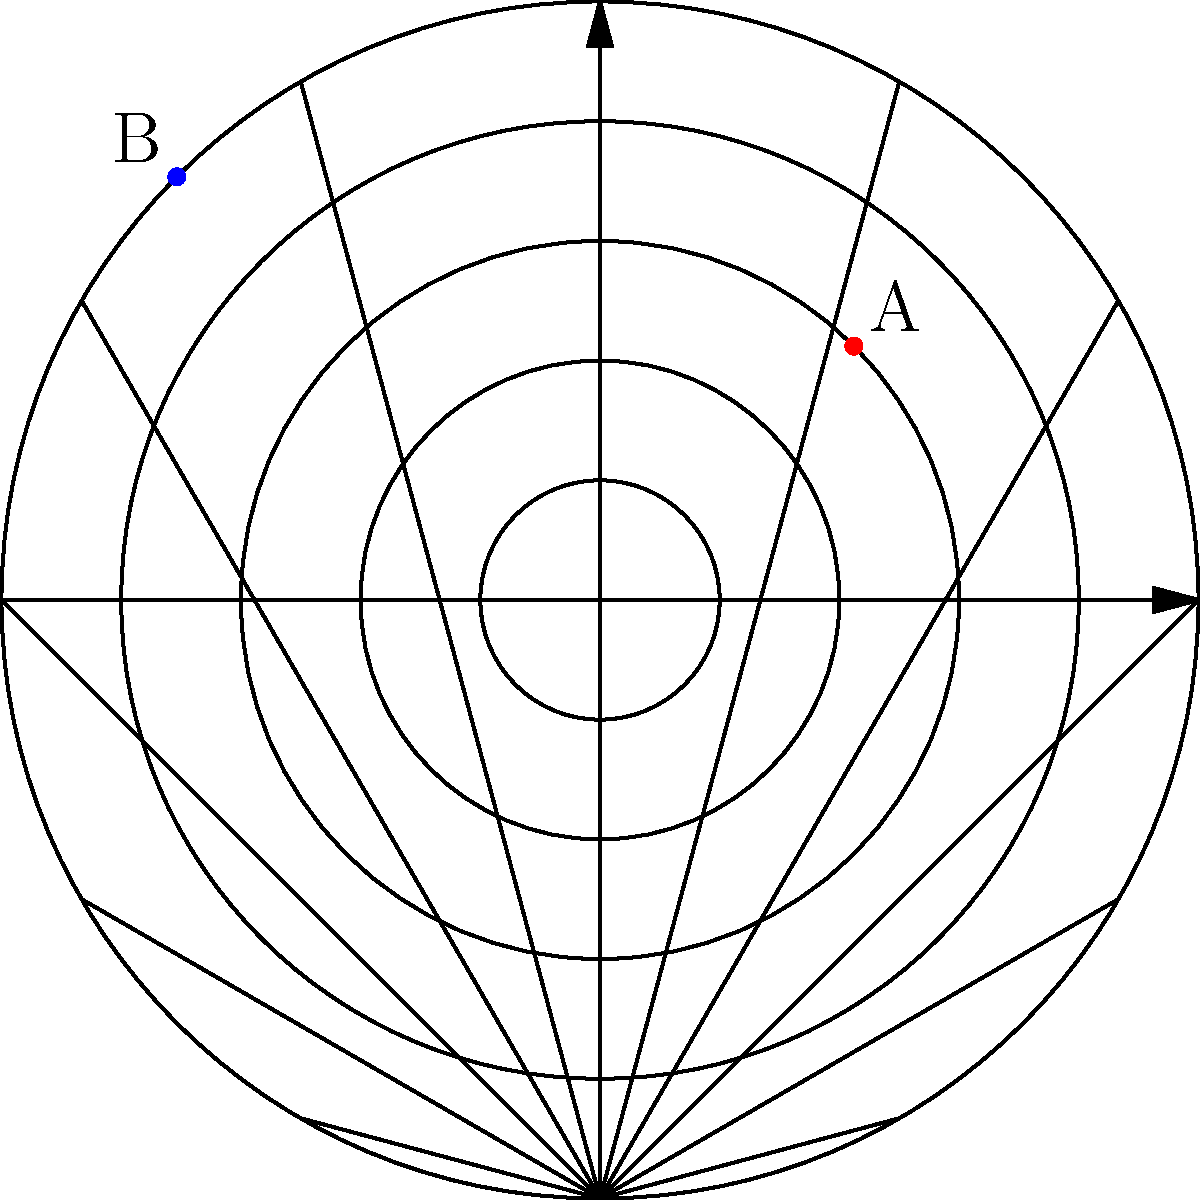Look at the polar grid above. Point A is at $(3, \frac{\pi}{4})$ and point B is at $(5, \frac{3\pi}{4})$. Can you find out how far apart these two points are? Let's solve this step-by-step:

1. In polar coordinates, we can't simply subtract the coordinates to find the distance. We need to use a special formula.

2. The formula to find the distance $d$ between two points $(r_1, \theta_1)$ and $(r_2, \theta_2)$ in polar coordinates is:

   $$d = \sqrt{r_1^2 + r_2^2 - 2r_1r_2 \cos(\theta_2 - \theta_1)}$$

3. We have:
   Point A: $r_1 = 3$, $\theta_1 = \frac{\pi}{4}$
   Point B: $r_2 = 5$, $\theta_2 = \frac{3\pi}{4}$

4. Let's substitute these into our formula:

   $$d = \sqrt{3^2 + 5^2 - 2(3)(5) \cos(\frac{3\pi}{4} - \frac{\pi}{4})}$$

5. Simplify inside the parentheses:
   $$d = \sqrt{9 + 25 - 30 \cos(\frac{\pi}{2})}$$

6. We know that $\cos(\frac{\pi}{2}) = 0$, so:
   $$d = \sqrt{9 + 25 - 0} = \sqrt{34}$$

7. $\sqrt{34}$ is approximately 5.83.
Answer: $\sqrt{34}$ or approximately 5.83 